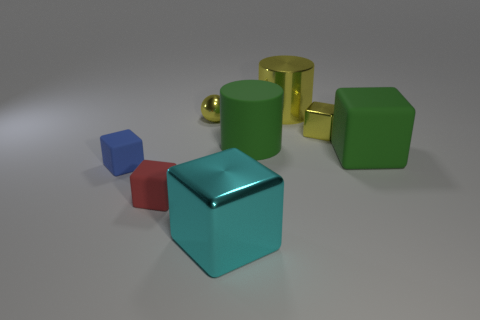Subtract all cyan blocks. How many blocks are left? 4 Subtract all cyan cubes. How many cubes are left? 4 Subtract all gray cubes. Subtract all red balls. How many cubes are left? 5 Add 2 large cubes. How many objects exist? 10 Subtract all cylinders. How many objects are left? 6 Add 5 tiny metallic balls. How many tiny metallic balls exist? 6 Subtract 0 green balls. How many objects are left? 8 Subtract all small purple objects. Subtract all rubber blocks. How many objects are left? 5 Add 3 tiny blue rubber cubes. How many tiny blue rubber cubes are left? 4 